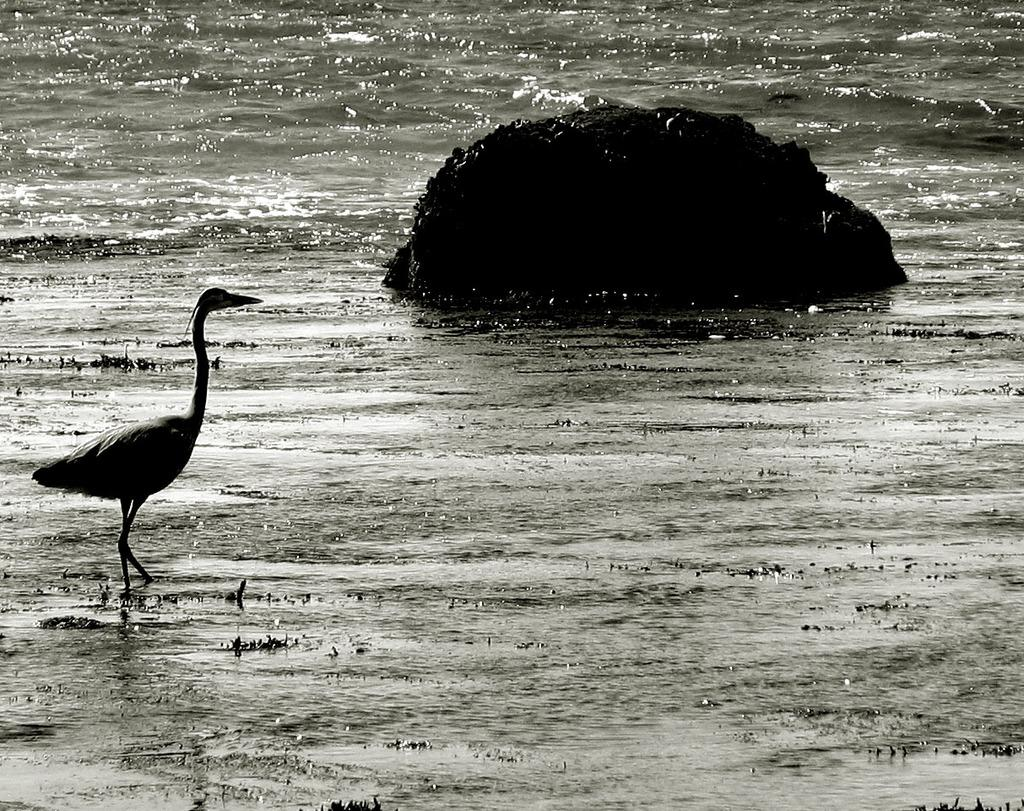What is the main feature of the image? The main feature of the image is a surface of water. What is located on the water? There is a rock on the water. What can be seen beside the rock? There is a bird standing beside the rock. What is visible in the background of the image? The background of the image includes water. How much money is floating on the water in the image? There is no money visible in the image; it only features a rock, a bird, and water. 